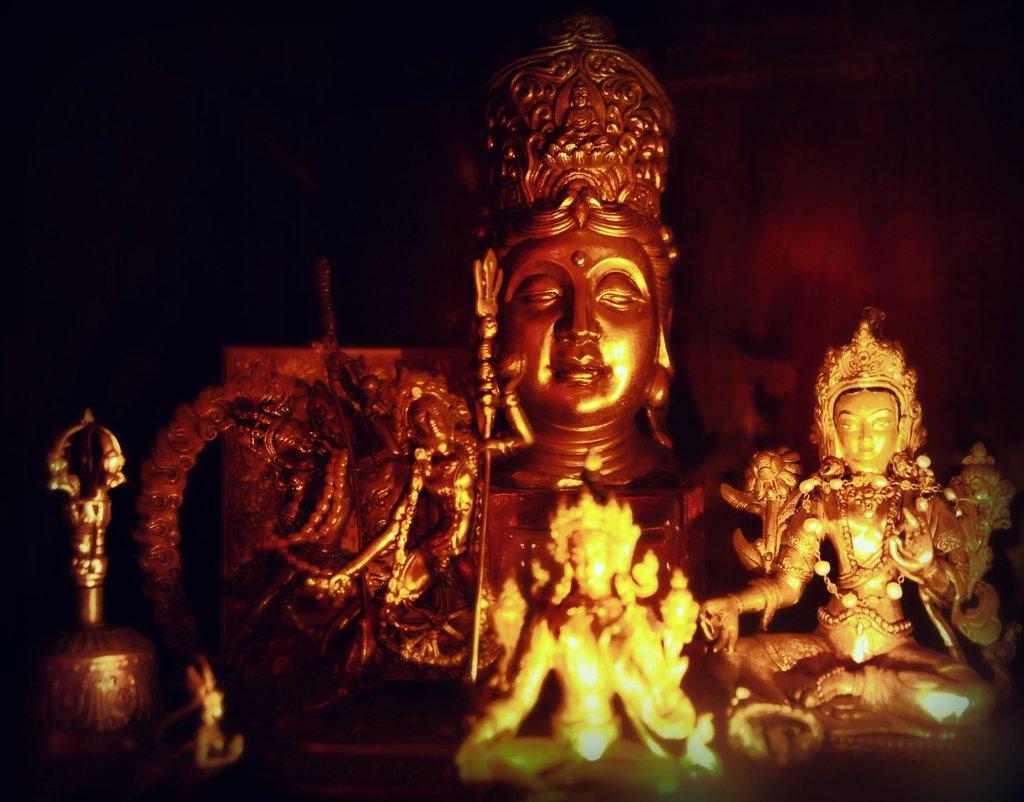Can you describe this image briefly? In the center of the image we can see sculptures and ornaments. And we can see the dark background. 